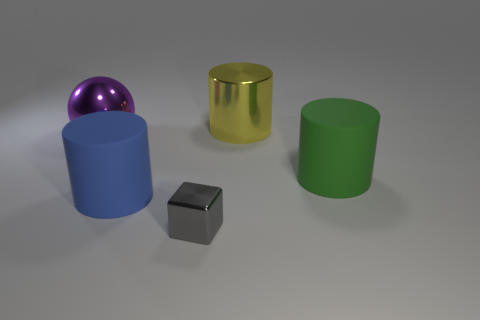Subtract all large matte cylinders. How many cylinders are left? 1 Add 3 small blue matte cylinders. How many objects exist? 8 Subtract all balls. How many objects are left? 4 Subtract 0 purple blocks. How many objects are left? 5 Subtract all large yellow matte cylinders. Subtract all spheres. How many objects are left? 4 Add 2 purple balls. How many purple balls are left? 3 Add 2 blue matte spheres. How many blue matte spheres exist? 2 